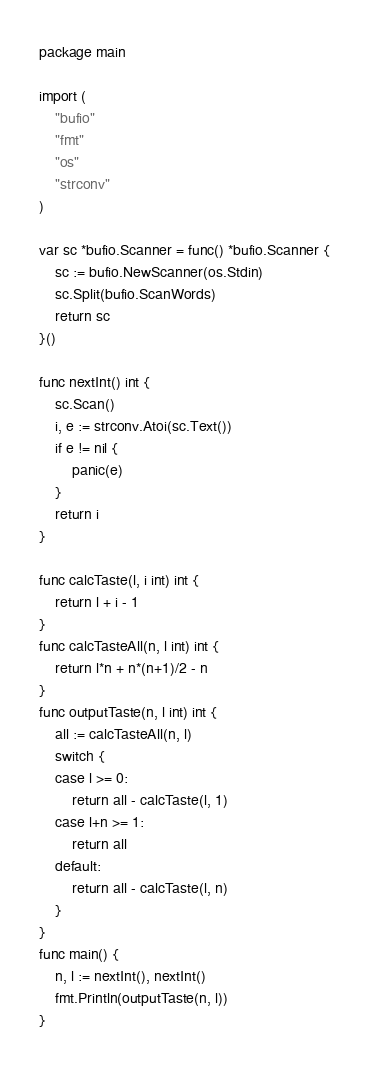Convert code to text. <code><loc_0><loc_0><loc_500><loc_500><_Go_>package main

import (
	"bufio"
	"fmt"
	"os"
	"strconv"
)

var sc *bufio.Scanner = func() *bufio.Scanner {
	sc := bufio.NewScanner(os.Stdin)
	sc.Split(bufio.ScanWords)
	return sc
}()

func nextInt() int {
	sc.Scan()
	i, e := strconv.Atoi(sc.Text())
	if e != nil {
		panic(e)
	}
	return i
}

func calcTaste(l, i int) int {
	return l + i - 1
}
func calcTasteAll(n, l int) int {
	return l*n + n*(n+1)/2 - n
}
func outputTaste(n, l int) int {
	all := calcTasteAll(n, l)
	switch {
	case l >= 0:
		return all - calcTaste(l, 1)
	case l+n >= 1:
		return all
	default:
		return all - calcTaste(l, n)
	}
}
func main() {
	n, l := nextInt(), nextInt()
	fmt.Println(outputTaste(n, l))
}
</code> 